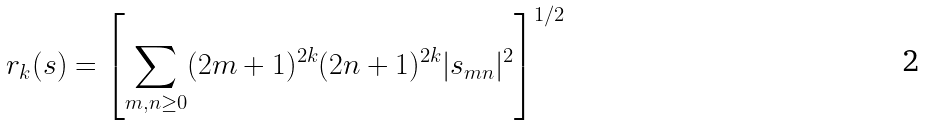Convert formula to latex. <formula><loc_0><loc_0><loc_500><loc_500>r _ { k } ( s ) = \left [ \sum _ { m , n \geq 0 } ( 2 m + 1 ) ^ { 2 k } ( 2 n + 1 ) ^ { 2 k } | s _ { m n } | ^ { 2 } \right ] ^ { 1 / 2 }</formula> 